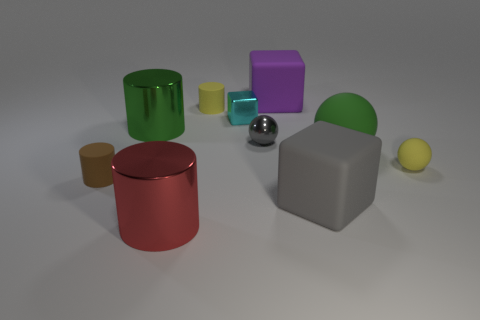If these objects were part of a game, what could the rules be? If these objects were part of a game, the rules could revolve around a sorting or matching challenge. For example, players might be tasked to group objects by material, size, or color within a time limit. Another possibility is a balancing game, where players would need to stack objects without them toppling over. A creative option might be a storytelling game, where each object represents a character or element of a narrative, and players build a story using the objects as prompts. 